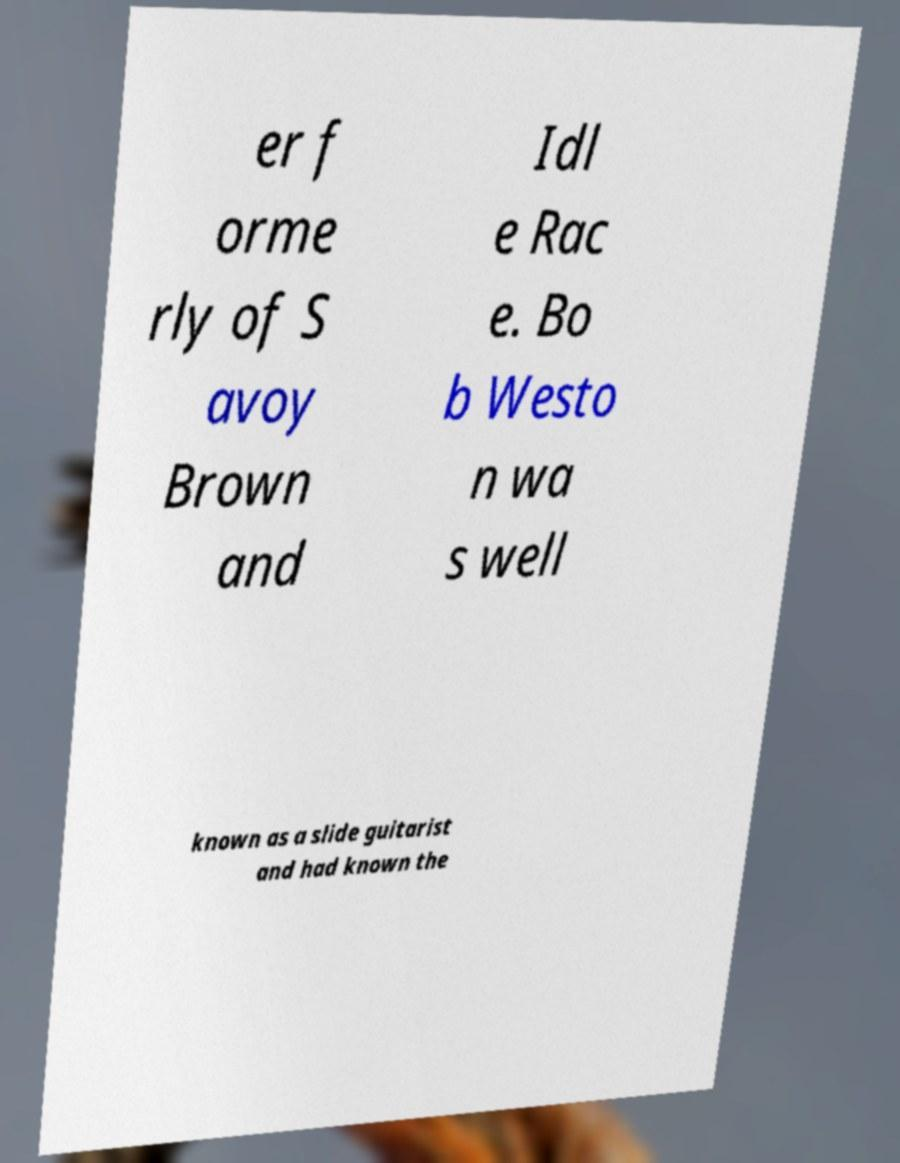I need the written content from this picture converted into text. Can you do that? er f orme rly of S avoy Brown and Idl e Rac e. Bo b Westo n wa s well known as a slide guitarist and had known the 